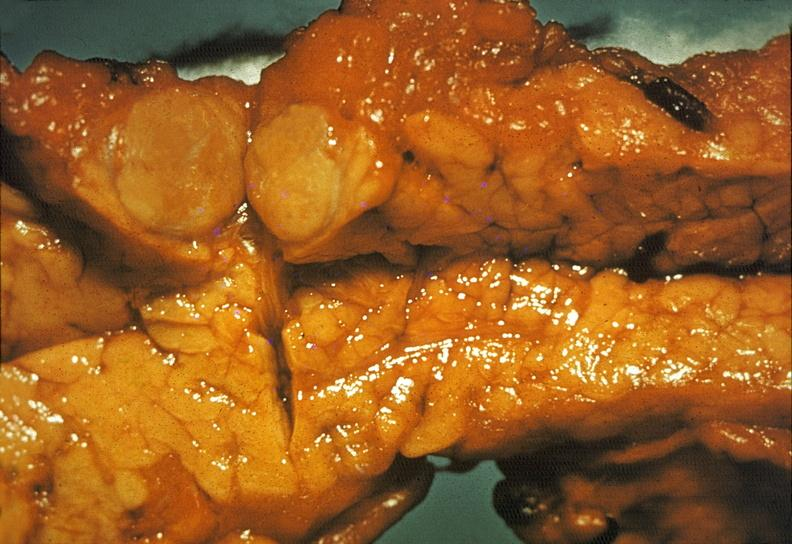what does this image show?
Answer the question using a single word or phrase. Islet cell carcinoma 